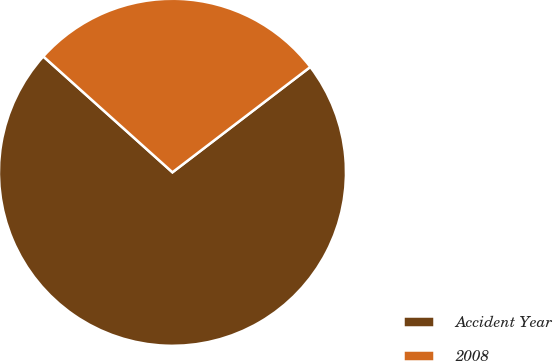Convert chart. <chart><loc_0><loc_0><loc_500><loc_500><pie_chart><fcel>Accident Year<fcel>2008<nl><fcel>72.02%<fcel>27.98%<nl></chart> 